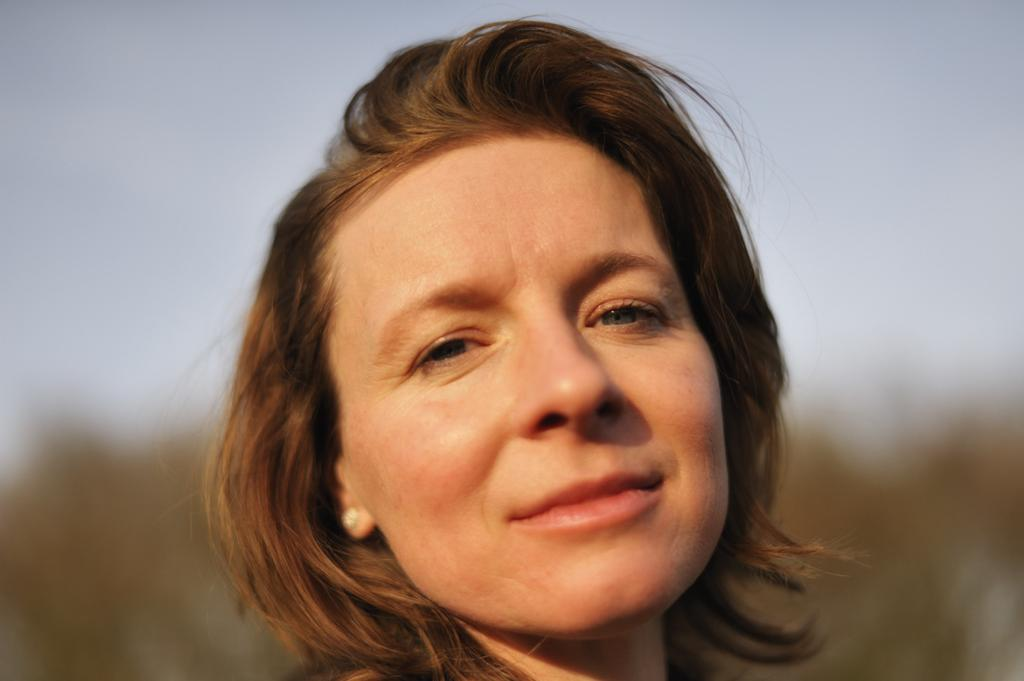Who is the main subject in the image? There is a woman in the image. Where is the woman located in the image? The woman is in the middle of the image. What can be seen in the background of the image? There is sky visible in the background of the image. What type of song is the woman singing in the image? There is no indication in the image that the woman is singing a song, so it cannot be determined from the picture. 